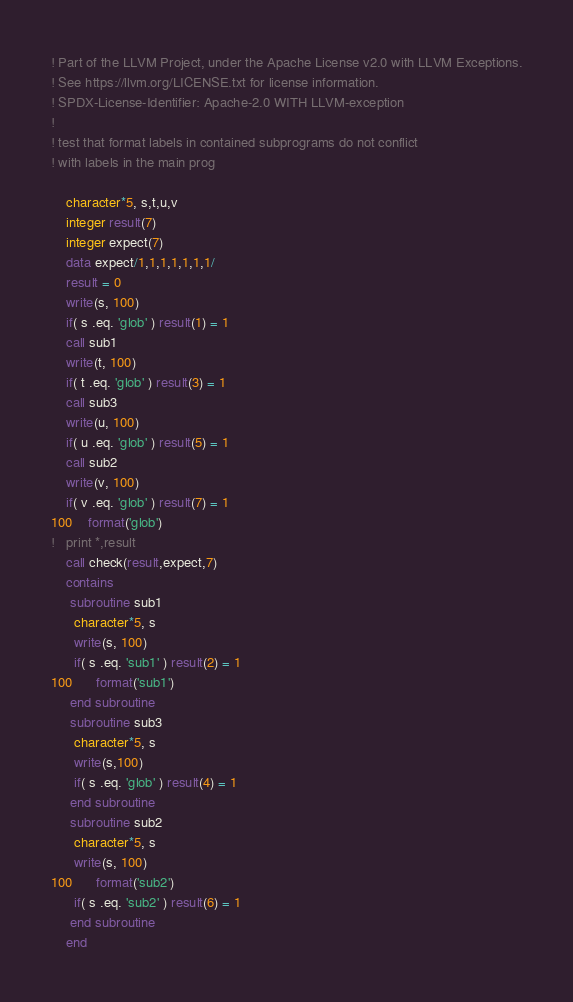<code> <loc_0><loc_0><loc_500><loc_500><_FORTRAN_>! Part of the LLVM Project, under the Apache License v2.0 with LLVM Exceptions.
! See https://llvm.org/LICENSE.txt for license information.
! SPDX-License-Identifier: Apache-2.0 WITH LLVM-exception
!
! test that format labels in contained subprograms do not conflict 
! with labels in the main prog

	character*5, s,t,u,v
	integer result(7)
	integer expect(7)
	data expect/1,1,1,1,1,1,1/
	result = 0
	write(s, 100)
	if( s .eq. 'glob' ) result(1) = 1
	call sub1
	write(t, 100)
	if( t .eq. 'glob' ) result(3) = 1
	call sub3
	write(u, 100)
	if( u .eq. 'glob' ) result(5) = 1
	call sub2
	write(v, 100)
	if( v .eq. 'glob' ) result(7) = 1
100	format('glob')
!	print *,result
	call check(result,expect,7)
	contains
	 subroutine sub1
	  character*5, s
	  write(s, 100)
	  if( s .eq. 'sub1' ) result(2) = 1
100	  format('sub1')
	 end subroutine
	 subroutine sub3
	  character*5, s
	  write(s,100)
	  if( s .eq. 'glob' ) result(4) = 1
	 end subroutine
	 subroutine sub2
	  character*5, s
	  write(s, 100)
100	  format('sub2')
	  if( s .eq. 'sub2' ) result(6) = 1
	 end subroutine
	end
</code> 